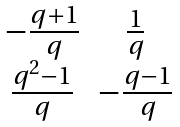<formula> <loc_0><loc_0><loc_500><loc_500>\begin{matrix} - \frac { q + 1 } { q } & \frac { 1 } { q } \\ \frac { q ^ { 2 } - 1 } { q } & - \frac { q - 1 } { q } \\ \end{matrix}</formula> 